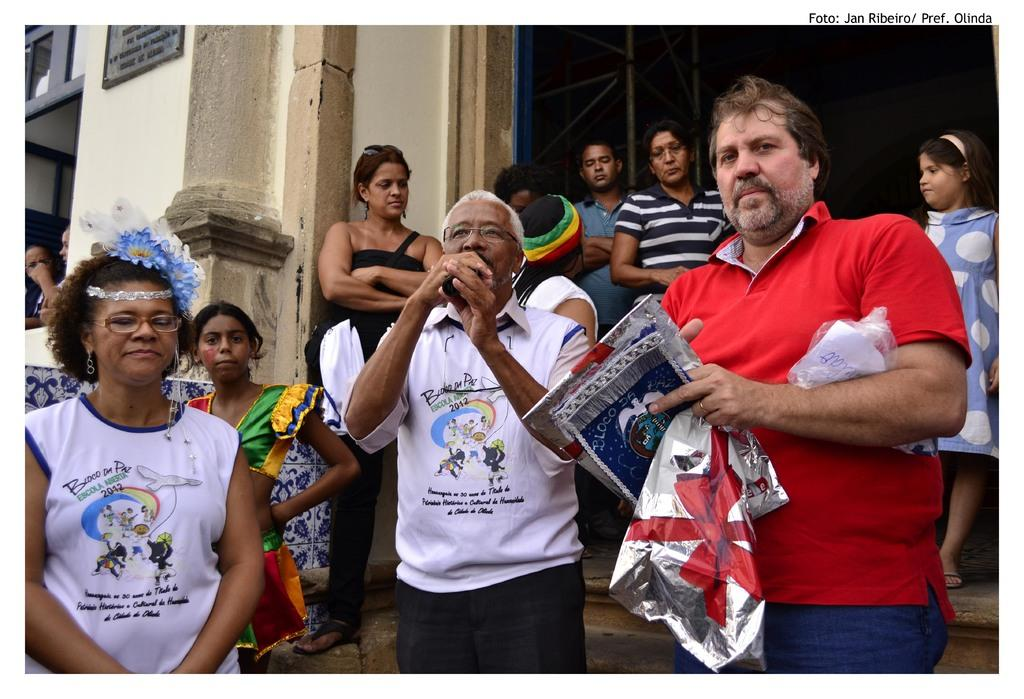What is happening in the image? There are people standing in the image, and one man is holding a microphone while another man is holding posters. What can be seen in the background of the image? There is a building in the background of the image. Is there a stream of water visible in the image? No, there is no stream of water present in the image. What type of work are the people in the image doing? The provided facts do not indicate what type of work the people are doing, as they are only described as holding a microphone and posters. 